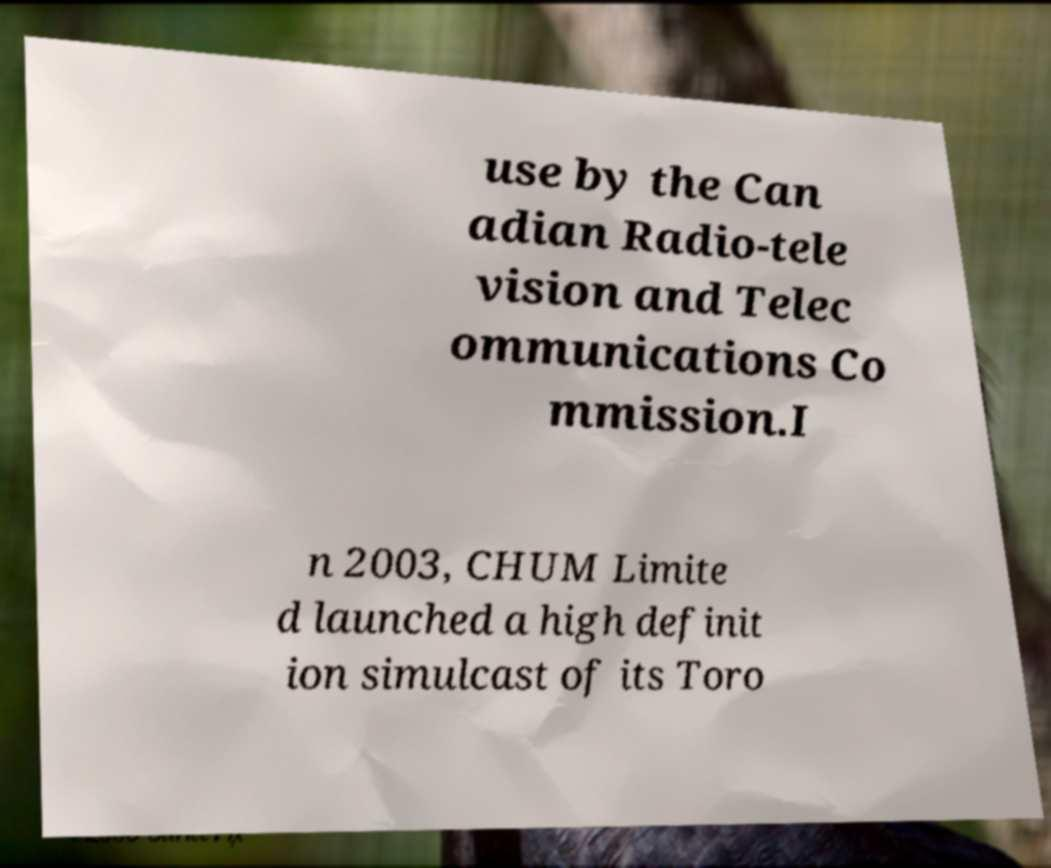Please identify and transcribe the text found in this image. use by the Can adian Radio-tele vision and Telec ommunications Co mmission.I n 2003, CHUM Limite d launched a high definit ion simulcast of its Toro 